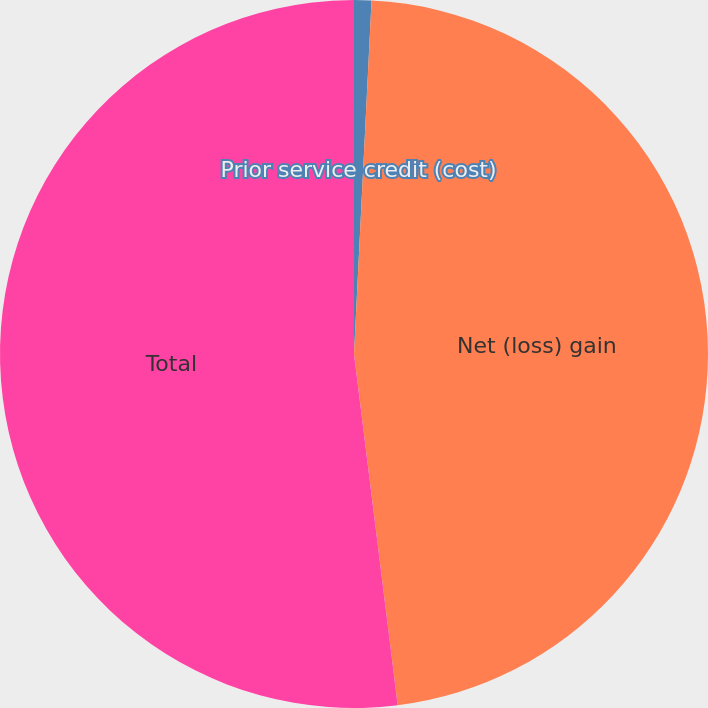Convert chart. <chart><loc_0><loc_0><loc_500><loc_500><pie_chart><fcel>Prior service credit (cost)<fcel>Net (loss) gain<fcel>Total<nl><fcel>0.79%<fcel>47.24%<fcel>51.97%<nl></chart> 